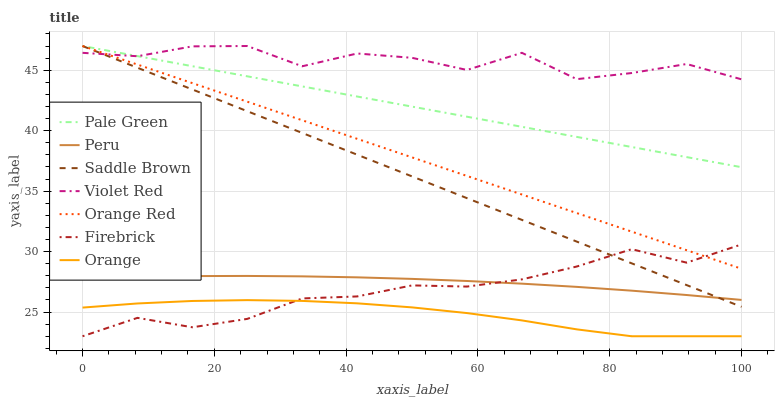Does Orange have the minimum area under the curve?
Answer yes or no. Yes. Does Violet Red have the maximum area under the curve?
Answer yes or no. Yes. Does Firebrick have the minimum area under the curve?
Answer yes or no. No. Does Firebrick have the maximum area under the curve?
Answer yes or no. No. Is Saddle Brown the smoothest?
Answer yes or no. Yes. Is Violet Red the roughest?
Answer yes or no. Yes. Is Firebrick the smoothest?
Answer yes or no. No. Is Firebrick the roughest?
Answer yes or no. No. Does Orange Red have the lowest value?
Answer yes or no. No. Does Saddle Brown have the highest value?
Answer yes or no. Yes. Does Firebrick have the highest value?
Answer yes or no. No. Is Orange less than Peru?
Answer yes or no. Yes. Is Orange Red greater than Orange?
Answer yes or no. Yes. Does Firebrick intersect Saddle Brown?
Answer yes or no. Yes. Is Firebrick less than Saddle Brown?
Answer yes or no. No. Is Firebrick greater than Saddle Brown?
Answer yes or no. No. Does Orange intersect Peru?
Answer yes or no. No. 